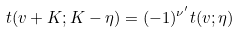Convert formula to latex. <formula><loc_0><loc_0><loc_500><loc_500>t ( v + K ; K - \eta ) = ( - 1 ) ^ { \nu ^ { \prime } } t ( v ; \eta )</formula> 